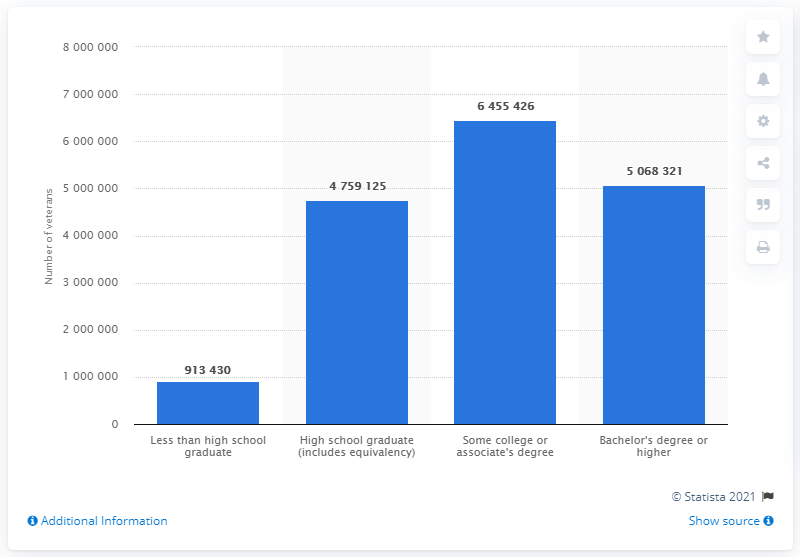Outline some significant characteristics in this image. In 2019, a total of 506,8321 veterans had attained a Bachelor's degree or higher. 